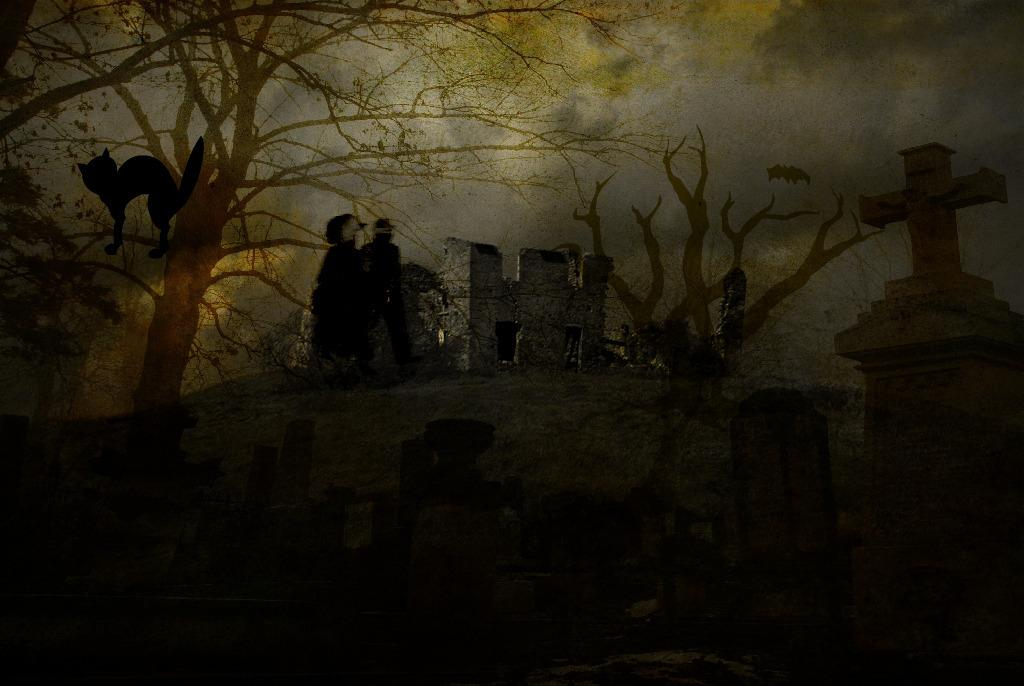What is the main setting of the image? There is a graveyard in the image. What type of natural elements can be seen in the image? There are trees in the image. Can you identify any animals in the image? It appears that there is a cat in the image. How many people are present in the image? There are two persons in the image. What other object can be seen in the image? There is a bat in the image. What type of humor can be seen in the image? There is no humor present in the image; it depicts a graveyard, trees, a cat, two persons, and a bat. Can you tell me how many attempts were made to capture the image? The number of attempts made to capture the image is not visible or mentioned in the image itself. 